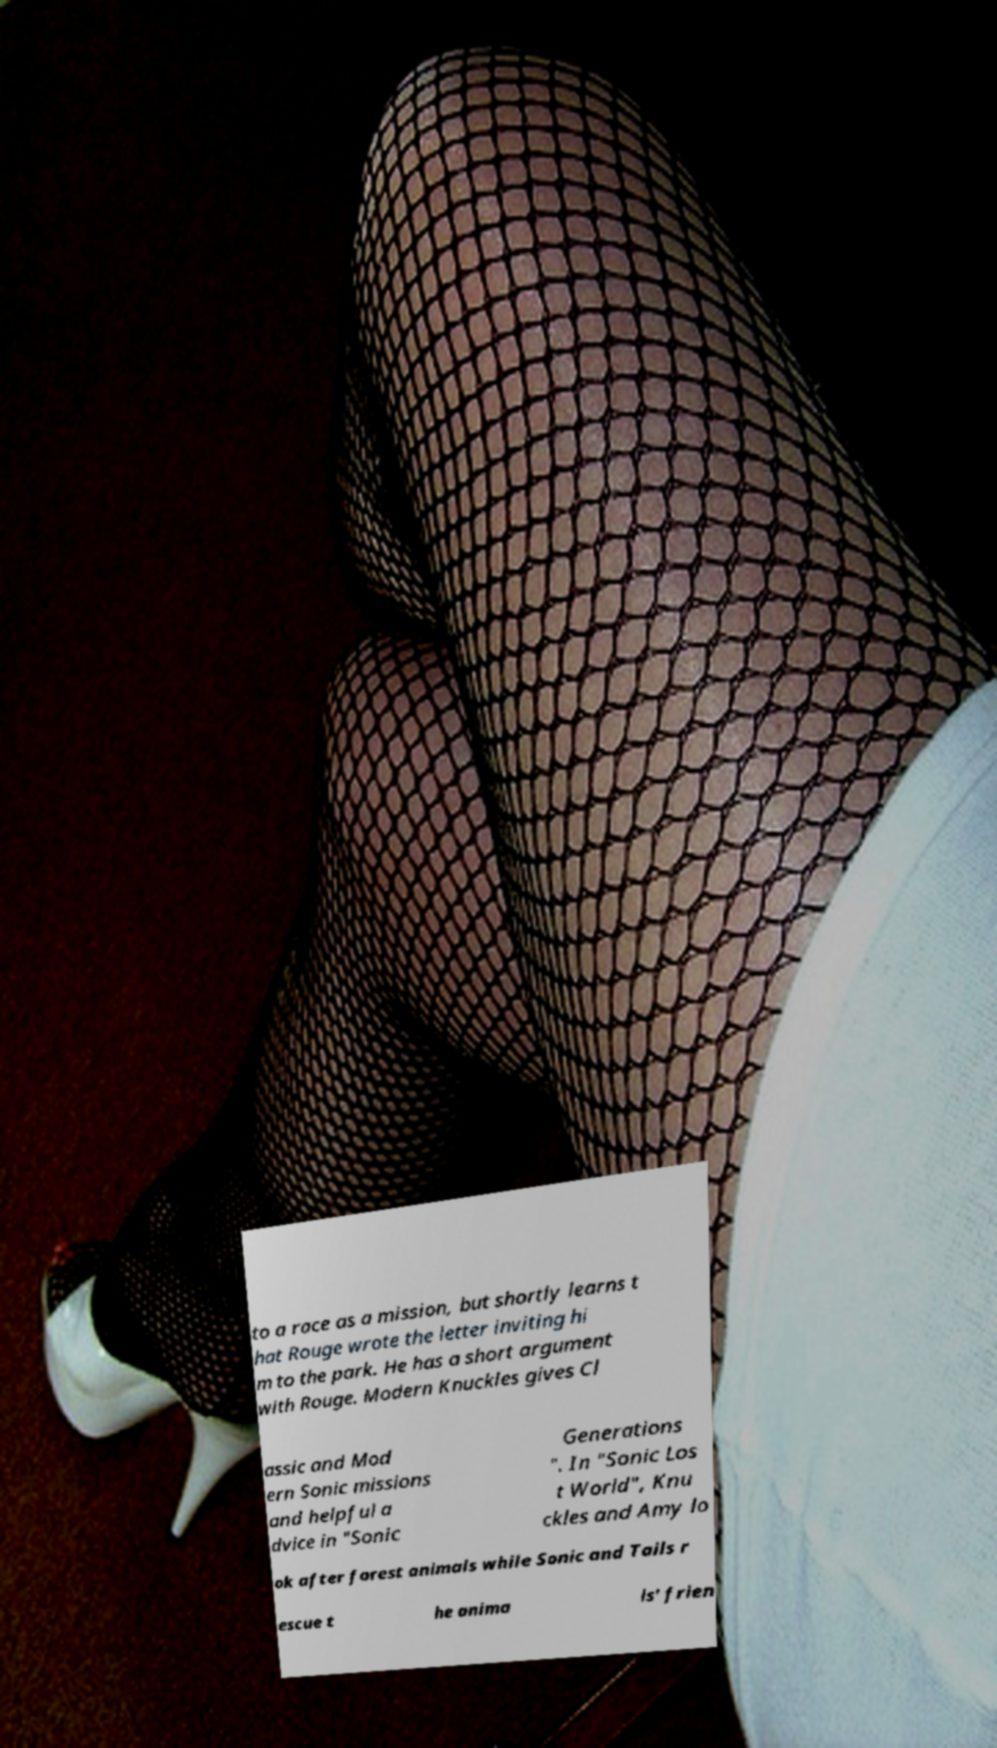Please read and relay the text visible in this image. What does it say? to a race as a mission, but shortly learns t hat Rouge wrote the letter inviting hi m to the park. He has a short argument with Rouge. Modern Knuckles gives Cl assic and Mod ern Sonic missions and helpful a dvice in "Sonic Generations ". In "Sonic Los t World", Knu ckles and Amy lo ok after forest animals while Sonic and Tails r escue t he anima ls' frien 